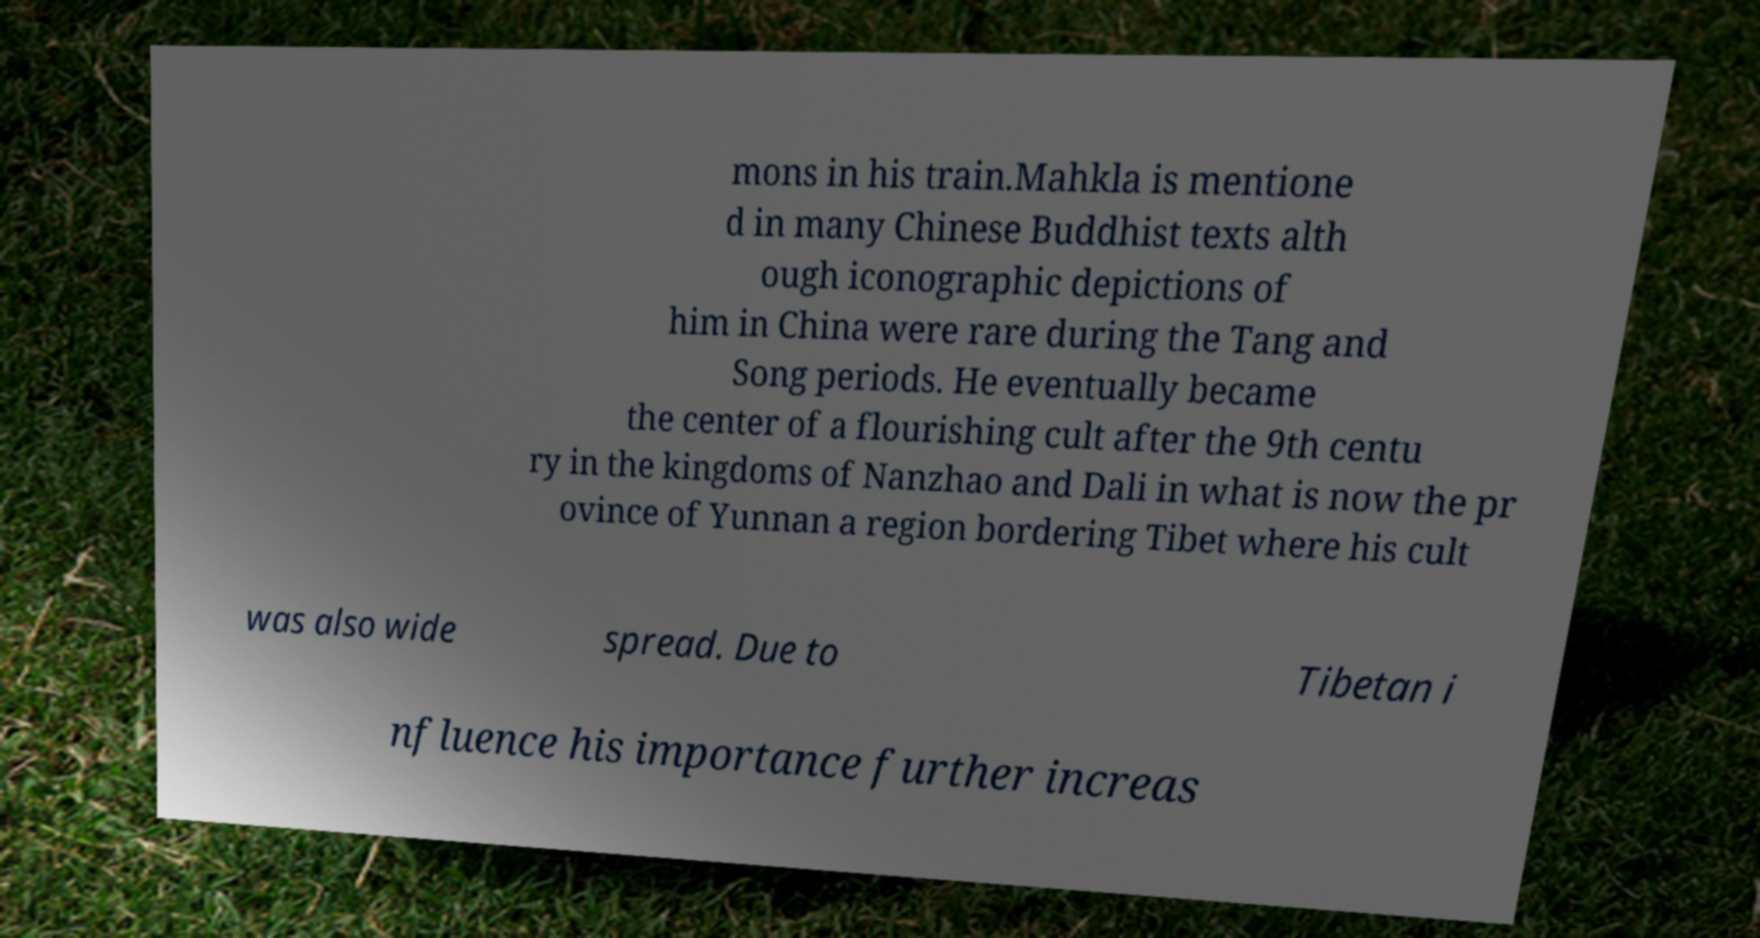There's text embedded in this image that I need extracted. Can you transcribe it verbatim? mons in his train.Mahkla is mentione d in many Chinese Buddhist texts alth ough iconographic depictions of him in China were rare during the Tang and Song periods. He eventually became the center of a flourishing cult after the 9th centu ry in the kingdoms of Nanzhao and Dali in what is now the pr ovince of Yunnan a region bordering Tibet where his cult was also wide spread. Due to Tibetan i nfluence his importance further increas 